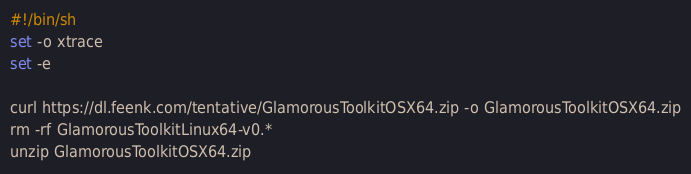<code> <loc_0><loc_0><loc_500><loc_500><_Bash_>#!/bin/sh
set -o xtrace
set -e

curl https://dl.feenk.com/tentative/GlamorousToolkitOSX64.zip -o GlamorousToolkitOSX64.zip
rm -rf GlamorousToolkitLinux64-v0.*
unzip GlamorousToolkitOSX64.zip</code> 